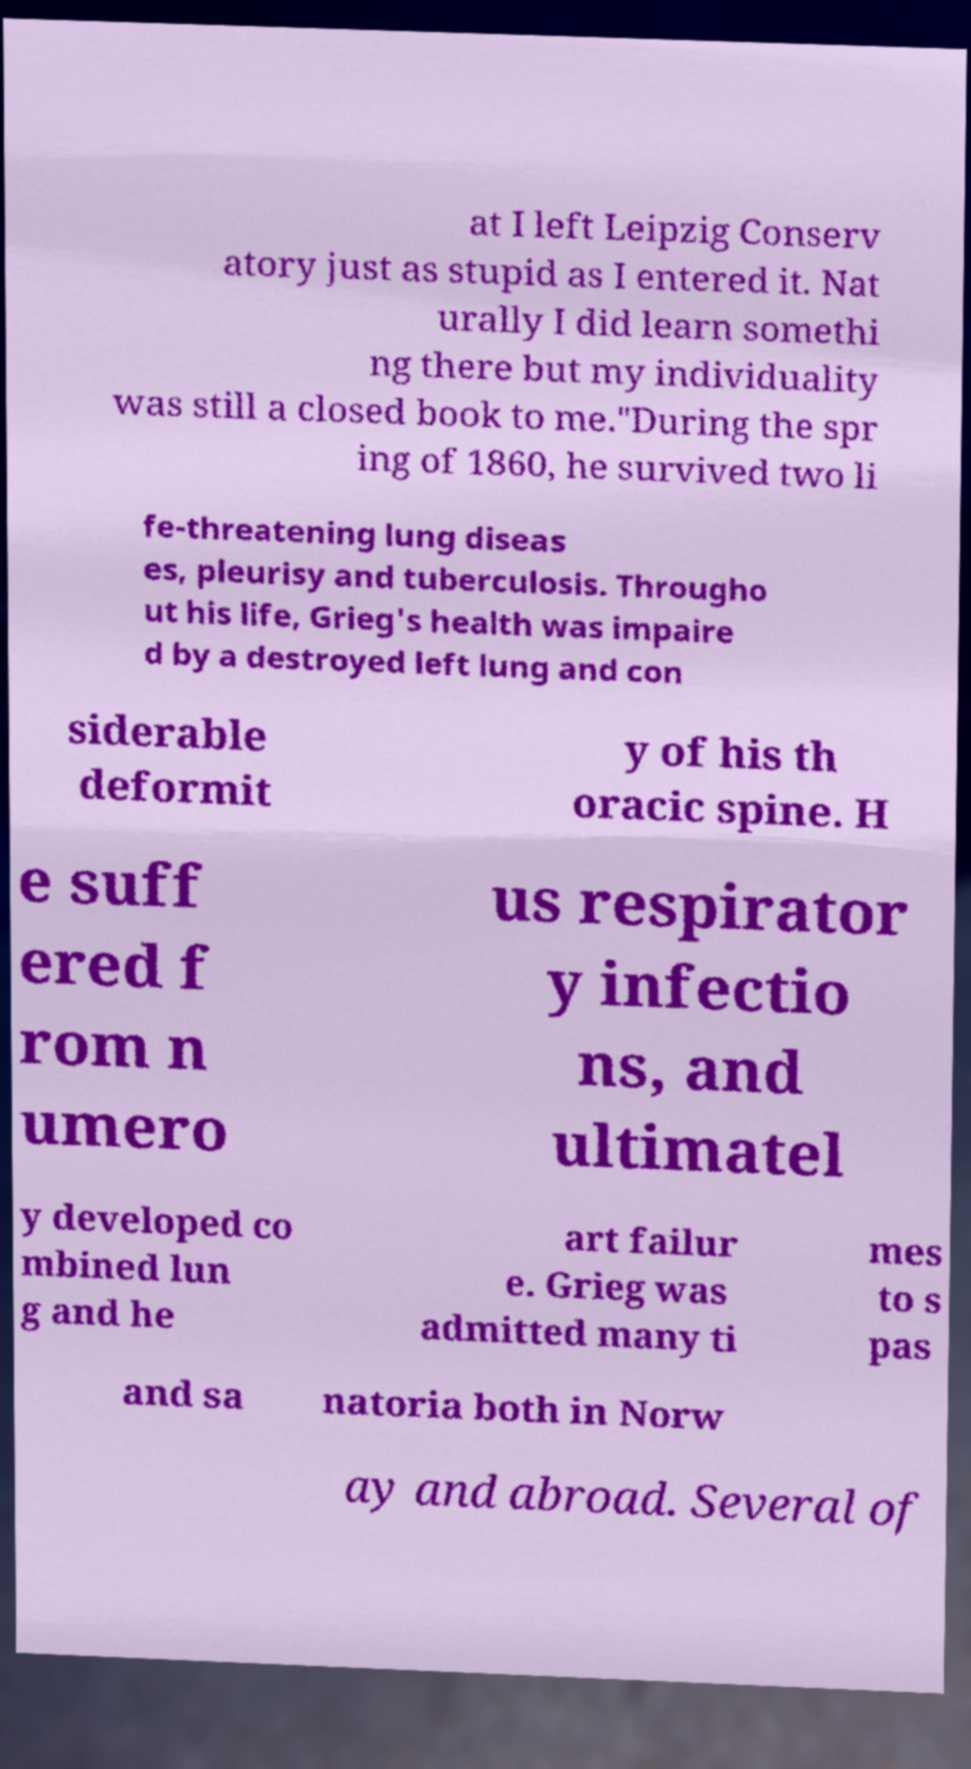Can you accurately transcribe the text from the provided image for me? at I left Leipzig Conserv atory just as stupid as I entered it. Nat urally I did learn somethi ng there but my individuality was still a closed book to me."During the spr ing of 1860, he survived two li fe-threatening lung diseas es, pleurisy and tuberculosis. Througho ut his life, Grieg's health was impaire d by a destroyed left lung and con siderable deformit y of his th oracic spine. H e suff ered f rom n umero us respirator y infectio ns, and ultimatel y developed co mbined lun g and he art failur e. Grieg was admitted many ti mes to s pas and sa natoria both in Norw ay and abroad. Several of 